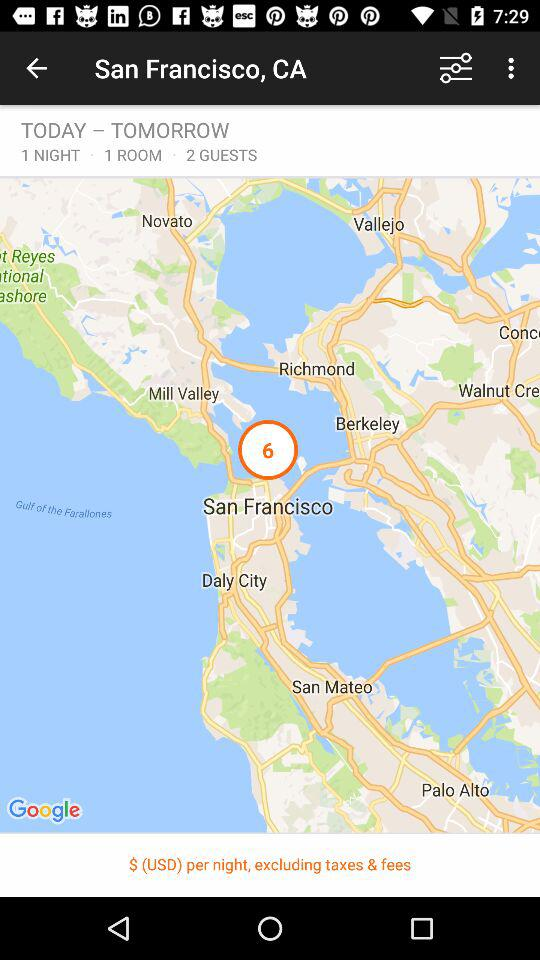What's the count of guests? The count of guests is 2. 